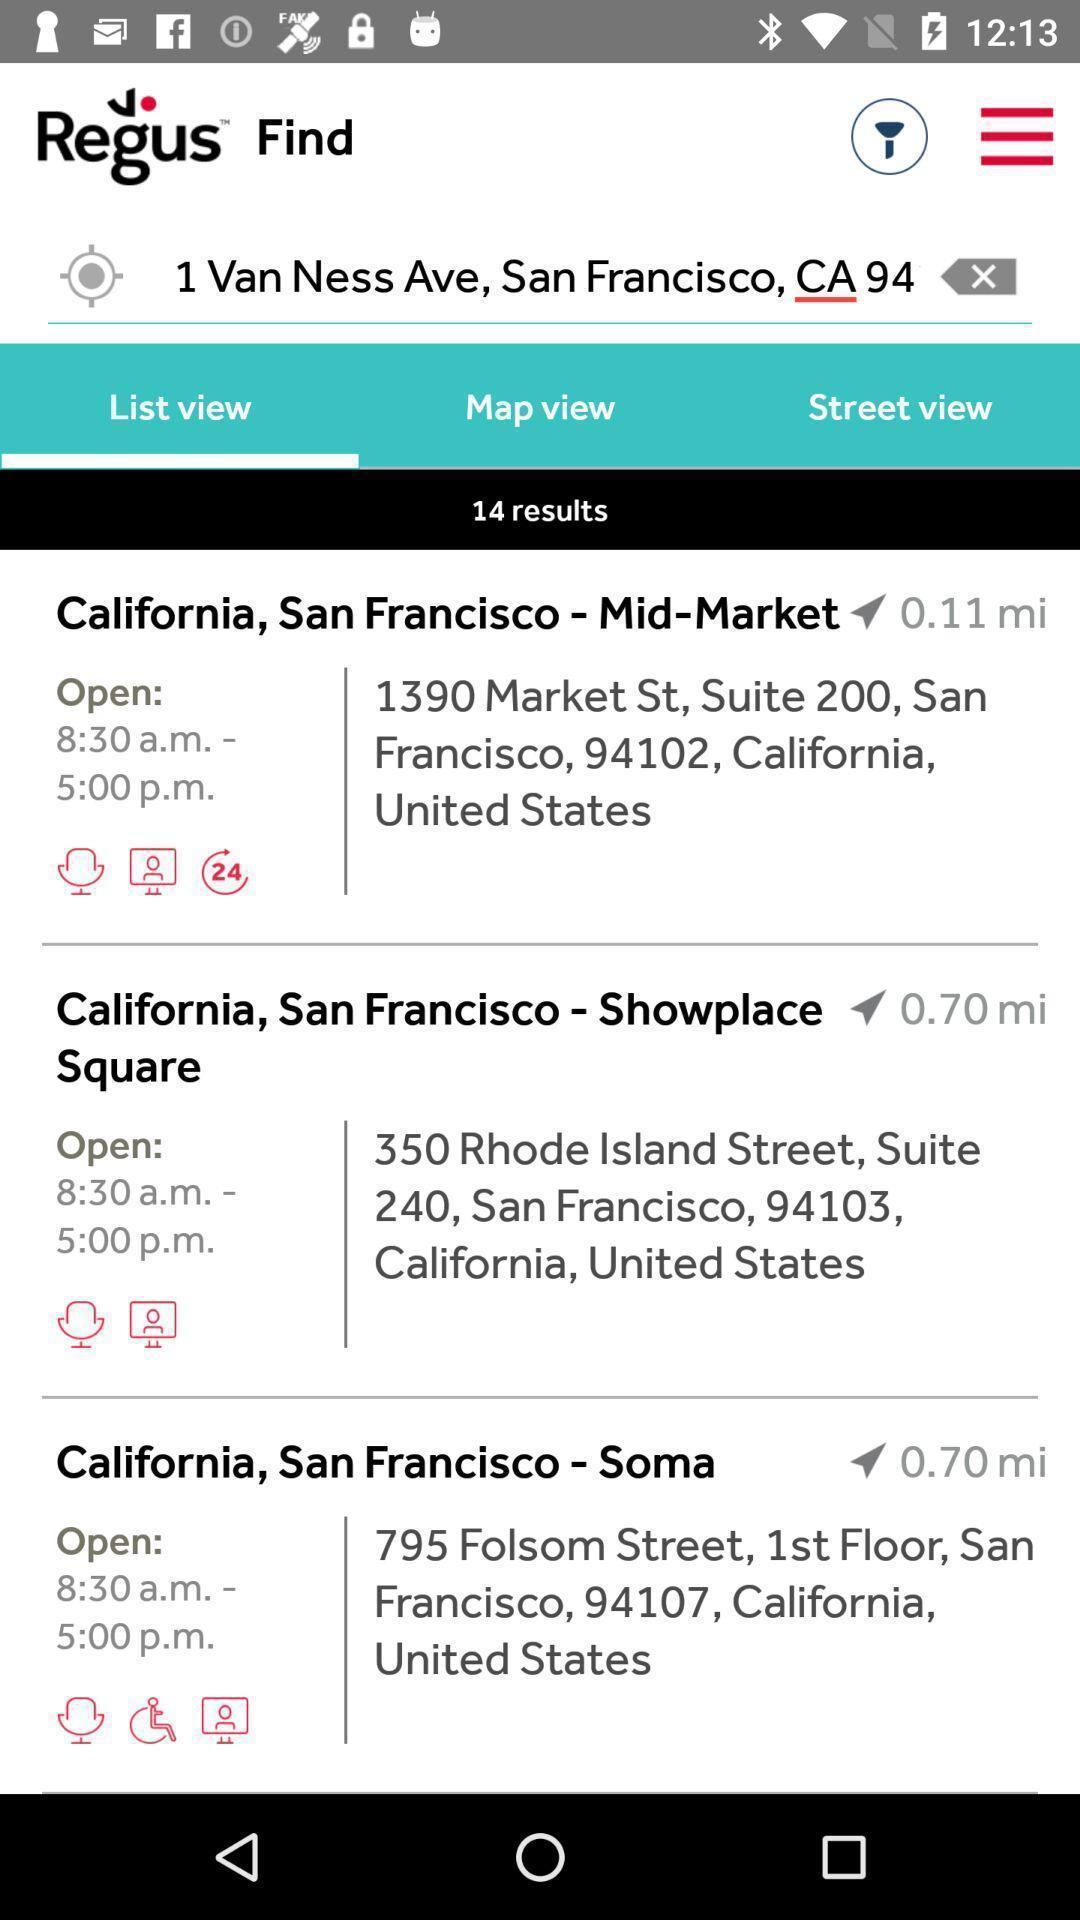Provide a detailed account of this screenshot. Screen displaying the list of locations nearby. 